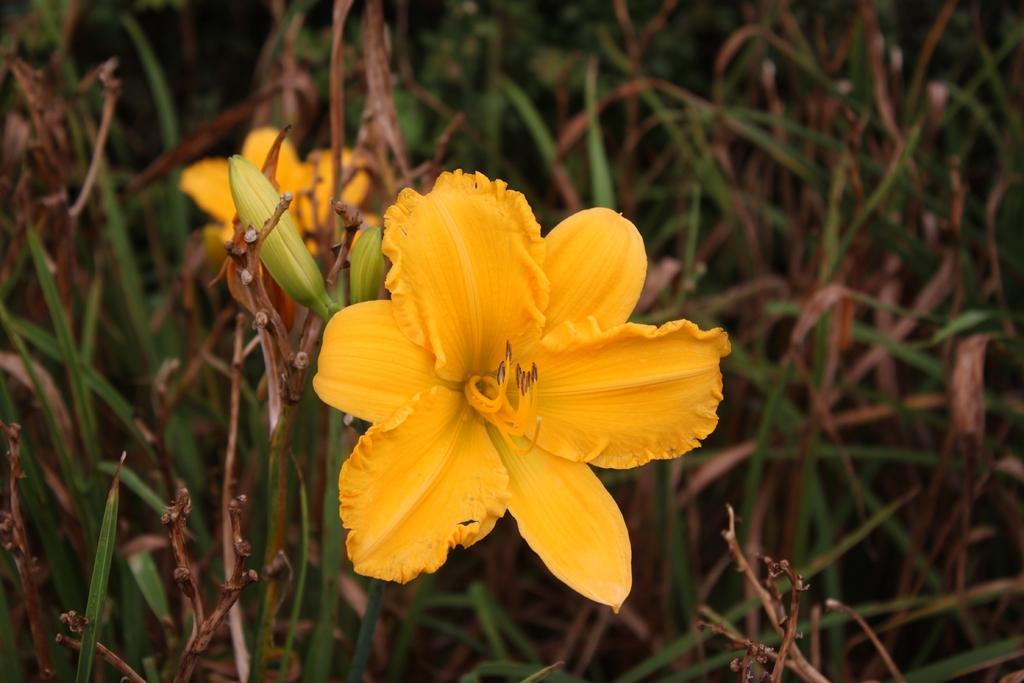Could you give a brief overview of what you see in this image? In this picture we can see the flowers, buds and plants. 